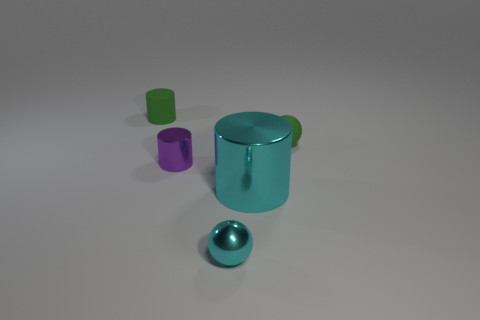Subtract all small cylinders. How many cylinders are left? 1 Add 1 metallic things. How many objects exist? 6 Subtract all green spheres. How many spheres are left? 1 Subtract all balls. How many objects are left? 3 Subtract 1 cylinders. How many cylinders are left? 2 Subtract all red blocks. How many cyan spheres are left? 1 Subtract 0 blue cylinders. How many objects are left? 5 Subtract all green cylinders. Subtract all blue spheres. How many cylinders are left? 2 Subtract all tiny green shiny cylinders. Subtract all shiny objects. How many objects are left? 2 Add 2 big cyan cylinders. How many big cyan cylinders are left? 3 